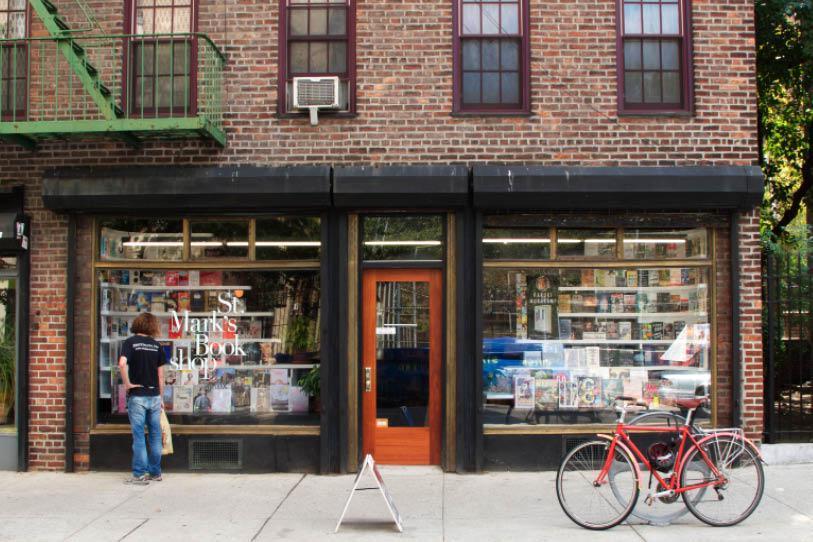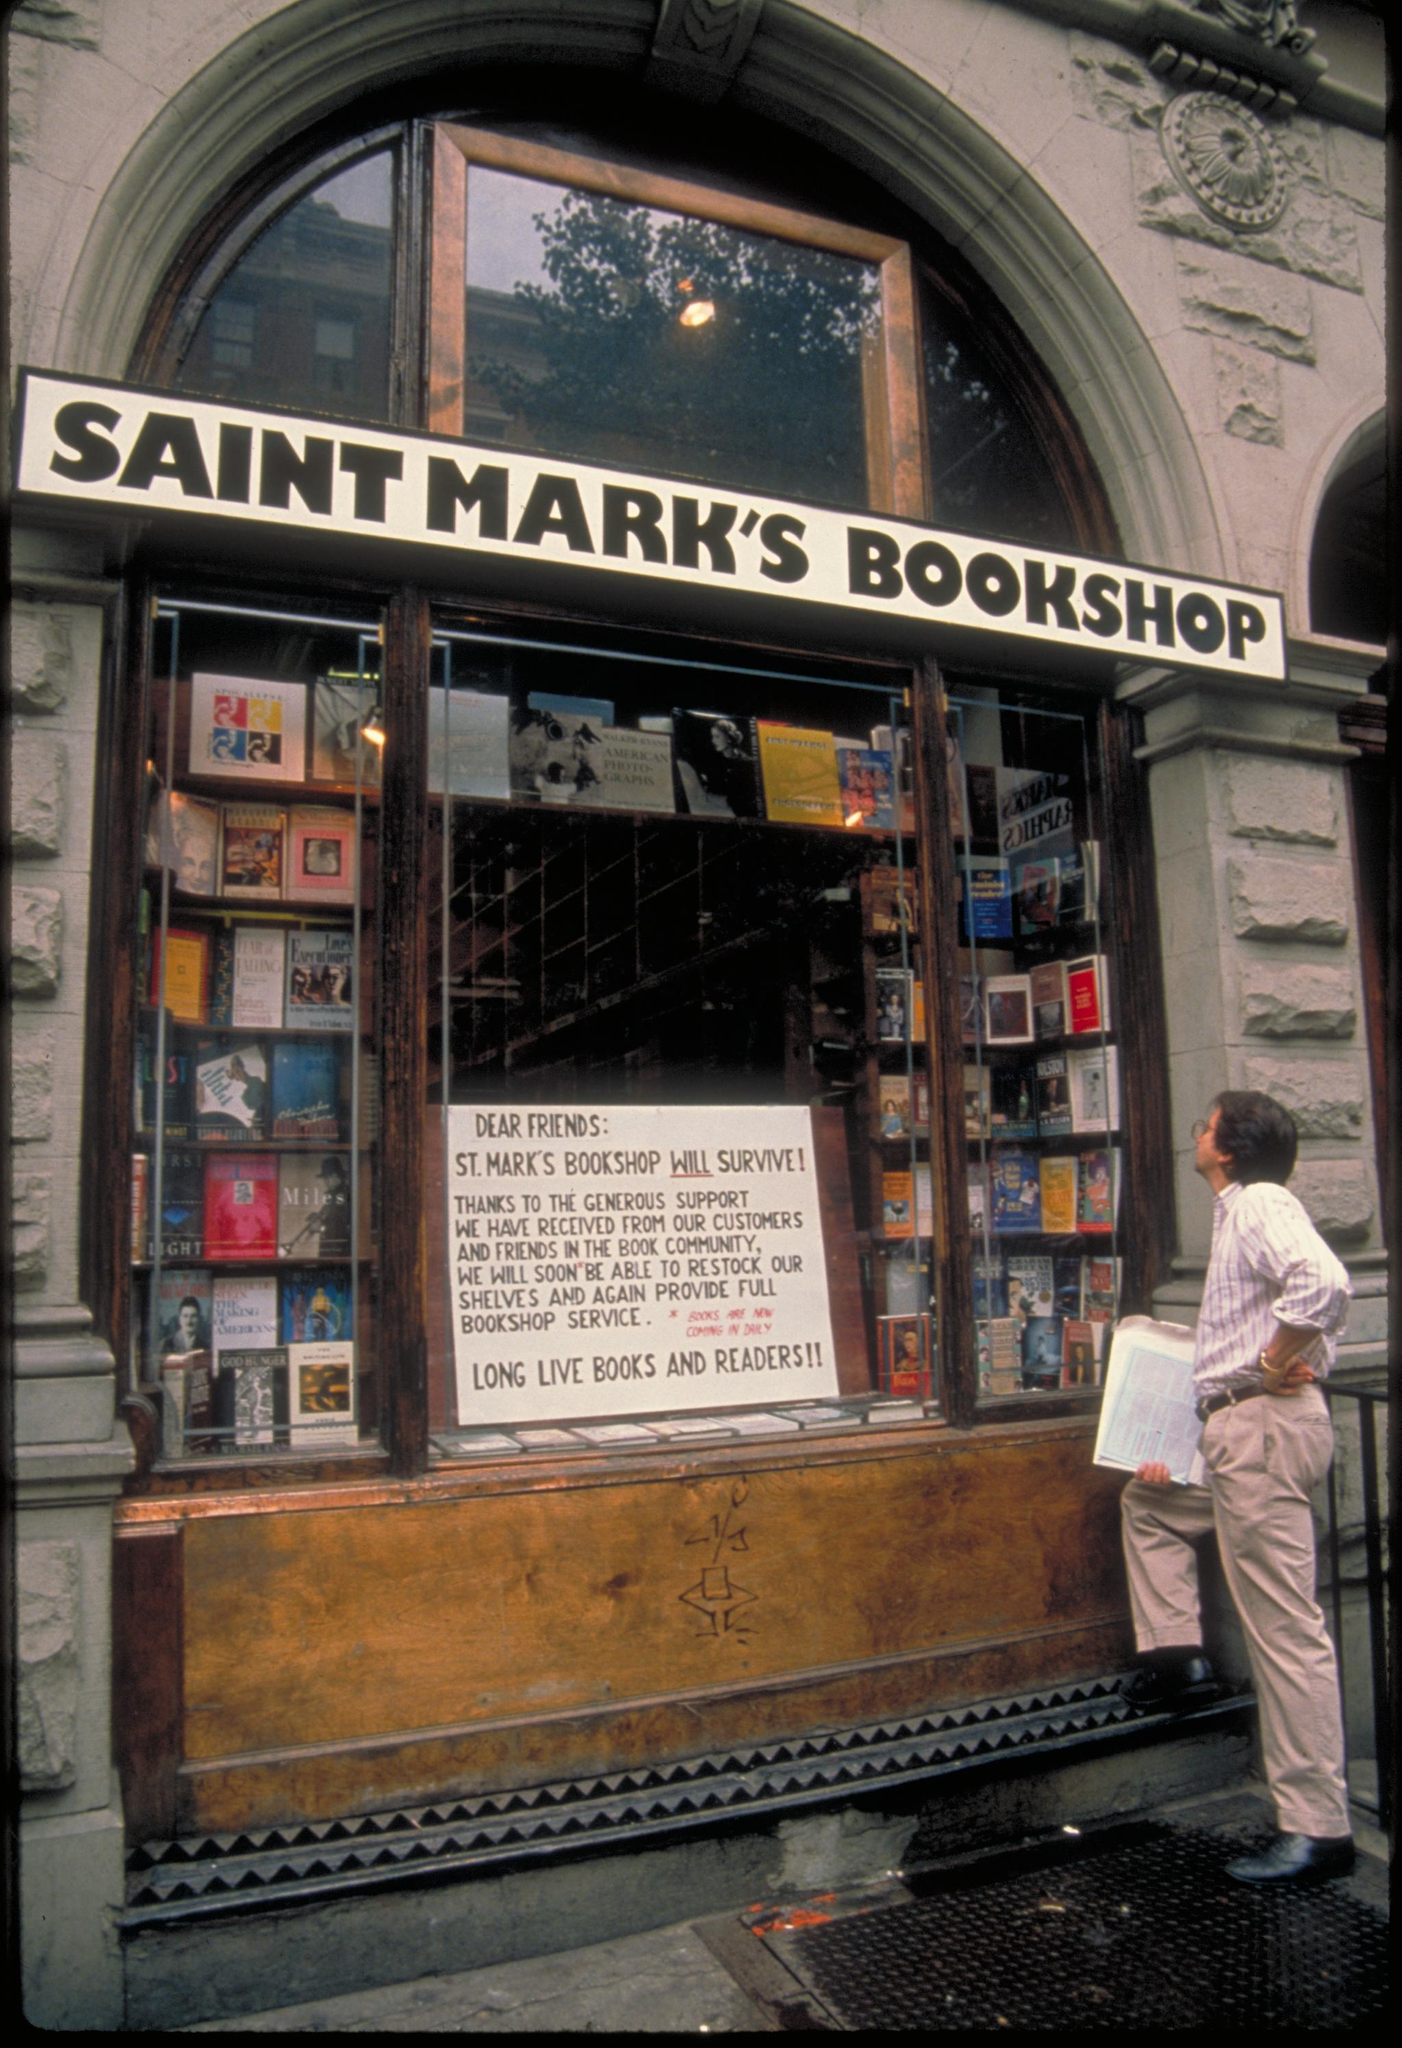The first image is the image on the left, the second image is the image on the right. Analyze the images presented: Is the assertion "All photos show only the exterior facade of the building." valid? Answer yes or no. Yes. 